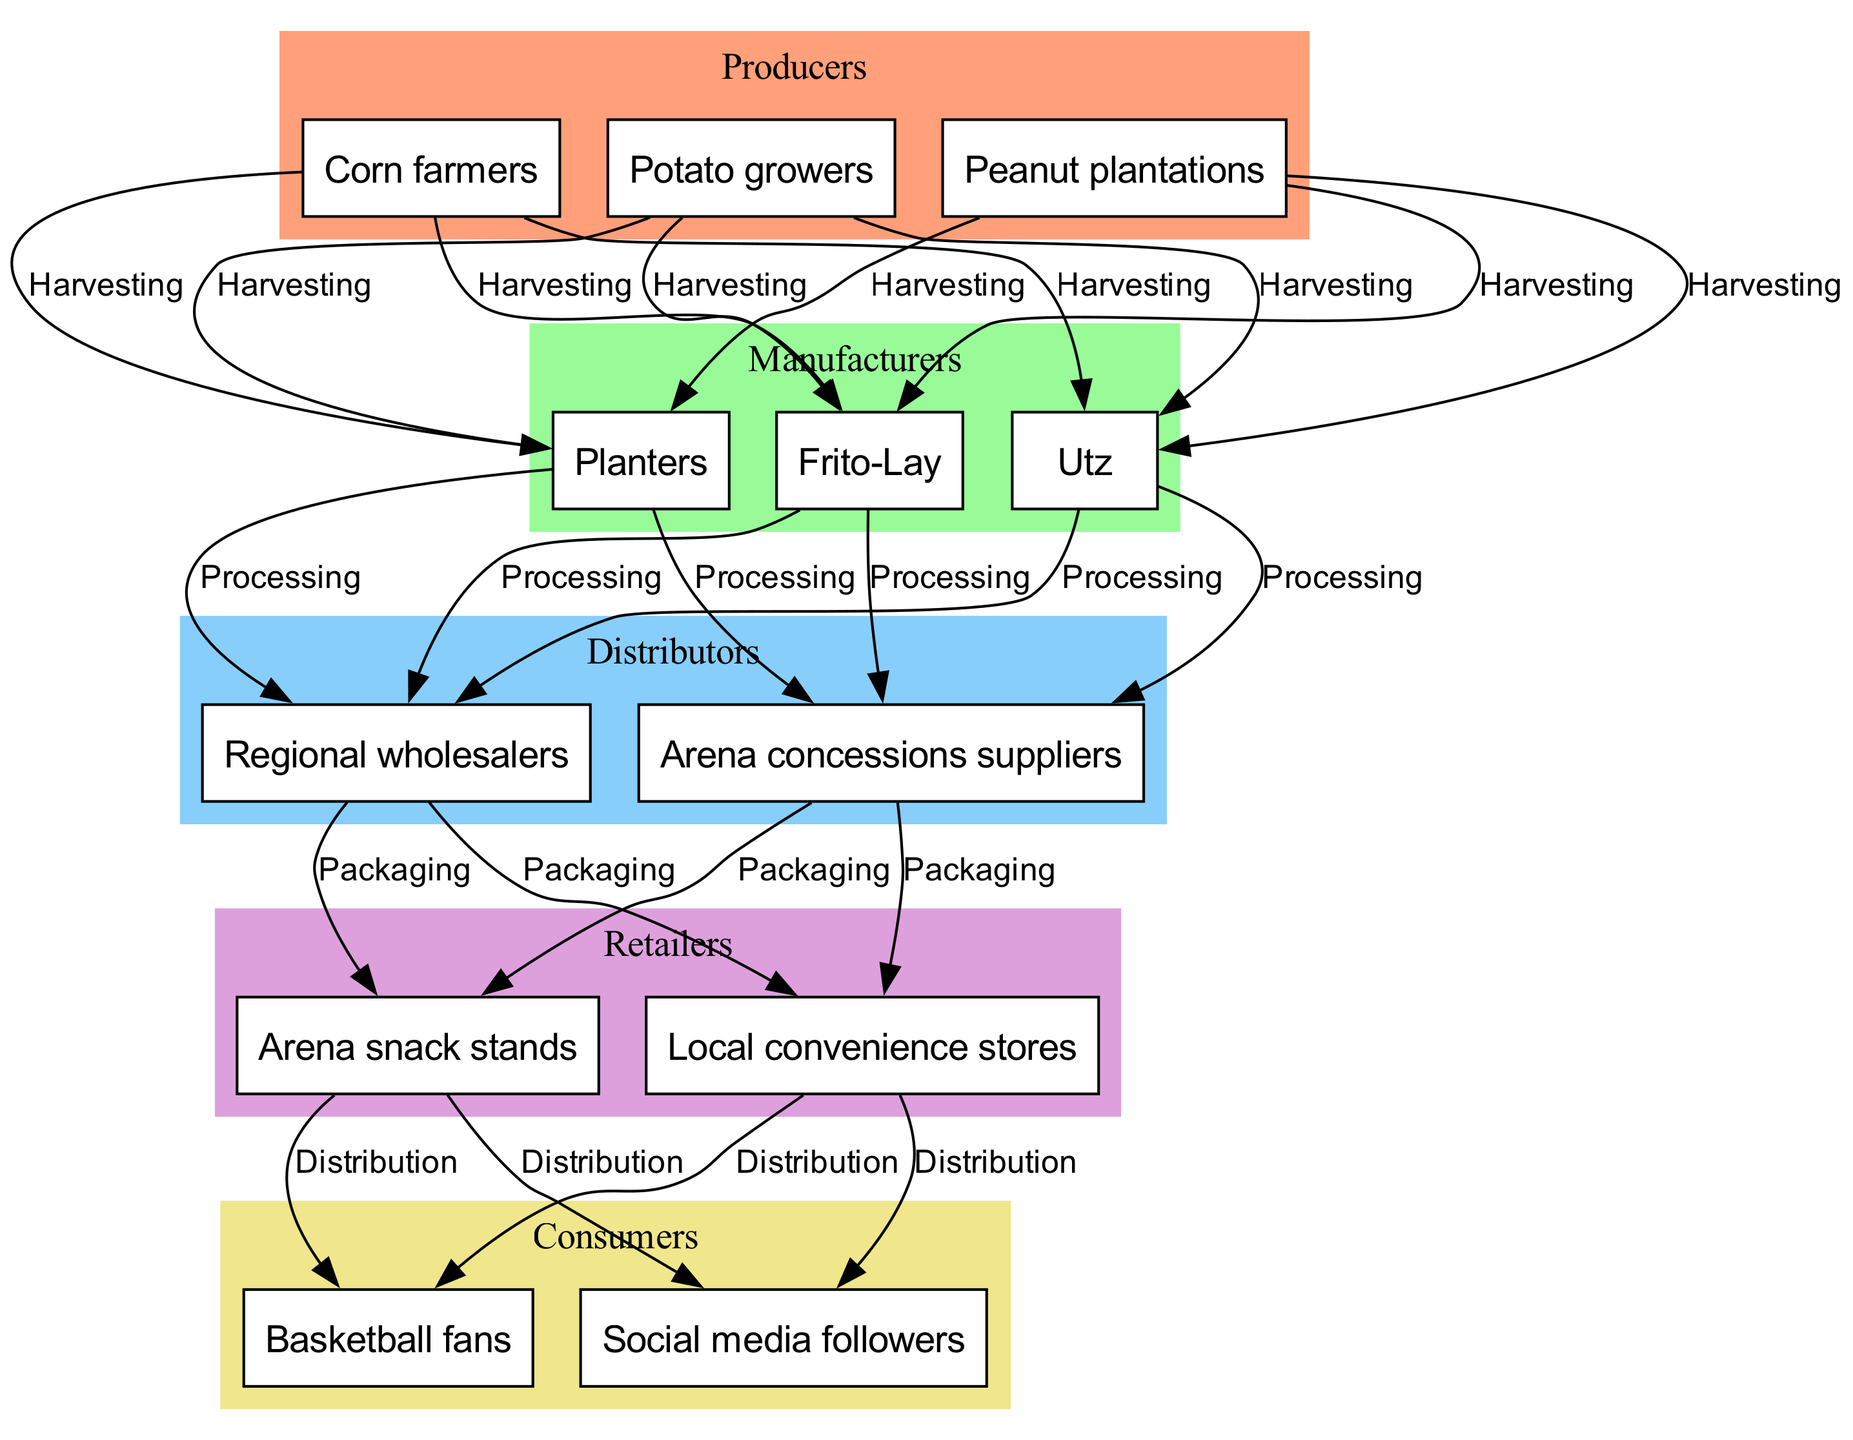What are the producers in the food chain? The producers in the diagram are listed in the "producers" category, which includes "Corn farmers," "Potato growers," and "Peanut plantations."
Answer: Corn farmers, Potato growers, Peanut plantations How many manufacturers are there in the food chain? By examining the "manufacturers" category, there are three manufacturers mentioned: "Frito-Lay," "Planters," and "Utz." Thus, the count is three.
Answer: 3 Which node connects the manufacturers to the distributors? The diagram indicates that the flow from "Manufacturers" to "Distributors" is characterized by the connection "Distribution." This relationship implies that manufacturers distribute their products to distributors.
Answer: Distribution Who are the consumers in the food chain? The consumers are explicitly stated in the "consumers" category, which includes "Basketball fans" and "Social media followers."
Answer: Basketball fans, Social media followers What is the last connection in the food chain? Analyzing the connections, the last stage listed is "Consumption," which indicates the final process where consumers utilize the snacks provided by the retailers.
Answer: Consumption Explain the flow from producers to consumers. The flow starts with "Corn farmers," "Potato growers," and "Peanut plantations" as producers. They process their products through "Frito-Lay," "Planters," and "Utz." Next, the products get distributed through "Regional wholesalers" and "Arena concessions suppliers." These then reach "Arena snack stands" and "Local convenience stores" as retailers. Finally, "Basketball fans" and "Social media followers" consume the snacks. This process illustrates the entire chain from production to consumption.
Answer: Producers to Manufacturers to Distributors to Retailers to Consumers Which category has the most nodes? Upon reviewing the diagram, both "producers" and "consumers" contain three nodes each. However, the other categories, like "manufacturers" and "distributors," have fewer nodes. Therefore, those categories with three nodes indicate the highest count.
Answer: Producers, Consumers What is the role of arena snack stands in the food chain? "Arena snack stands" serve as the retailers in the chain, providing snacks directly to consumers, specifically basketball fans attending games. They fulfill the retail function of selling products sourced from distributors.
Answer: Retailer What connects the distributors to retailers? The direct connection from "Distributors" to "Retailers" is through the "Sales" connection, indicating that distributors sell the products to retailers like snack stands and convenience stores.
Answer: Sales 